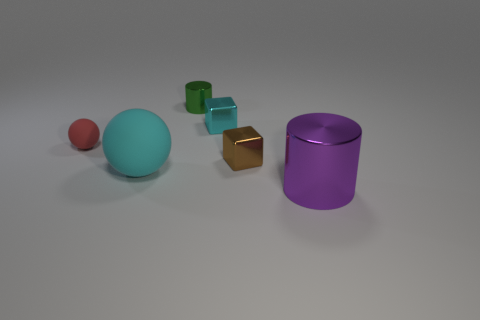Add 4 large cyan balls. How many objects exist? 10 Add 6 big brown matte cylinders. How many big brown matte cylinders exist? 6 Subtract 1 red spheres. How many objects are left? 5 Subtract all spheres. How many objects are left? 4 Subtract all small brown rubber balls. Subtract all small cyan metallic objects. How many objects are left? 5 Add 2 blocks. How many blocks are left? 4 